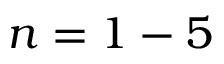Convert formula to latex. <formula><loc_0><loc_0><loc_500><loc_500>n = 1 - 5</formula> 